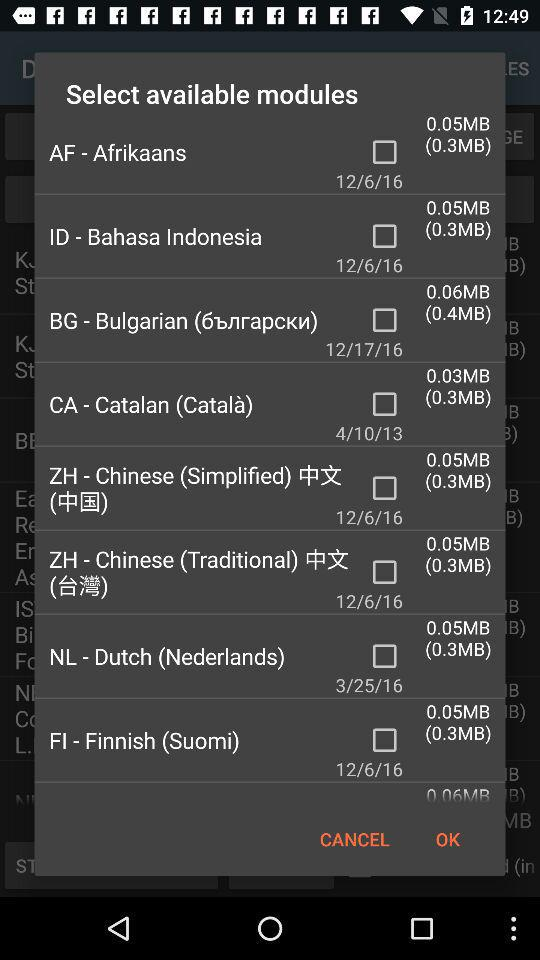What is the data size of "CA - Catalan (Català)"? The data size of "CA - Catalan (Català)" is 0.03 MB. 